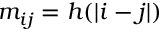<formula> <loc_0><loc_0><loc_500><loc_500>m _ { i j } = h ( | i - j | )</formula> 